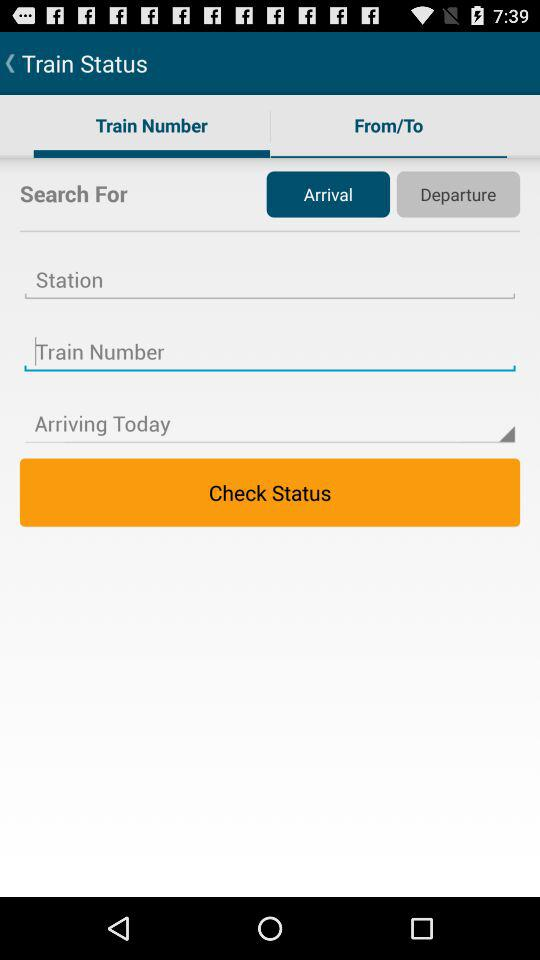Which tab is selected? The selected tab is "Train Number". 